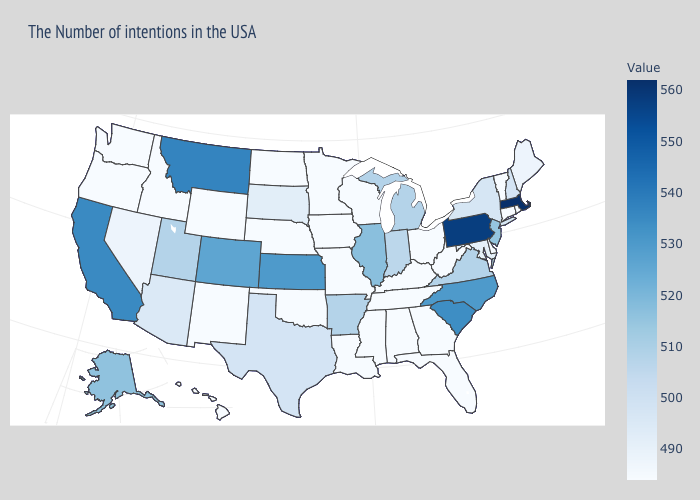Which states hav the highest value in the MidWest?
Be succinct. Kansas. Among the states that border Florida , which have the lowest value?
Answer briefly. Georgia, Alabama. Which states have the lowest value in the USA?
Give a very brief answer. Rhode Island, Vermont, Connecticut, Delaware, West Virginia, Ohio, Florida, Georgia, Kentucky, Alabama, Tennessee, Wisconsin, Mississippi, Louisiana, Missouri, Minnesota, Iowa, Nebraska, Oklahoma, North Dakota, Wyoming, New Mexico, Idaho, Washington, Oregon, Hawaii. Does the map have missing data?
Write a very short answer. No. Among the states that border Virginia , which have the lowest value?
Concise answer only. West Virginia, Kentucky, Tennessee. Does Rhode Island have the lowest value in the Northeast?
Be succinct. Yes. Does Washington have the lowest value in the West?
Write a very short answer. Yes. Does Delaware have a lower value than Pennsylvania?
Answer briefly. Yes. Does Washington have the highest value in the West?
Answer briefly. No. 